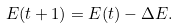<formula> <loc_0><loc_0><loc_500><loc_500>E ( t + 1 ) = E ( t ) - \Delta E .</formula> 